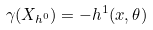<formula> <loc_0><loc_0><loc_500><loc_500>\gamma ( X _ { h ^ { 0 } } ) = - h ^ { 1 } ( x , \theta )</formula> 